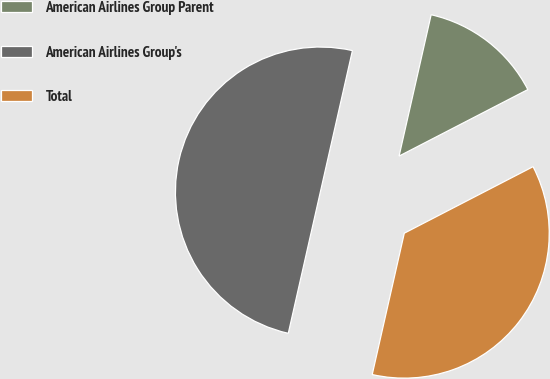Convert chart. <chart><loc_0><loc_0><loc_500><loc_500><pie_chart><fcel>American Airlines Group Parent<fcel>American Airlines Group's<fcel>Total<nl><fcel>13.86%<fcel>50.0%<fcel>36.14%<nl></chart> 